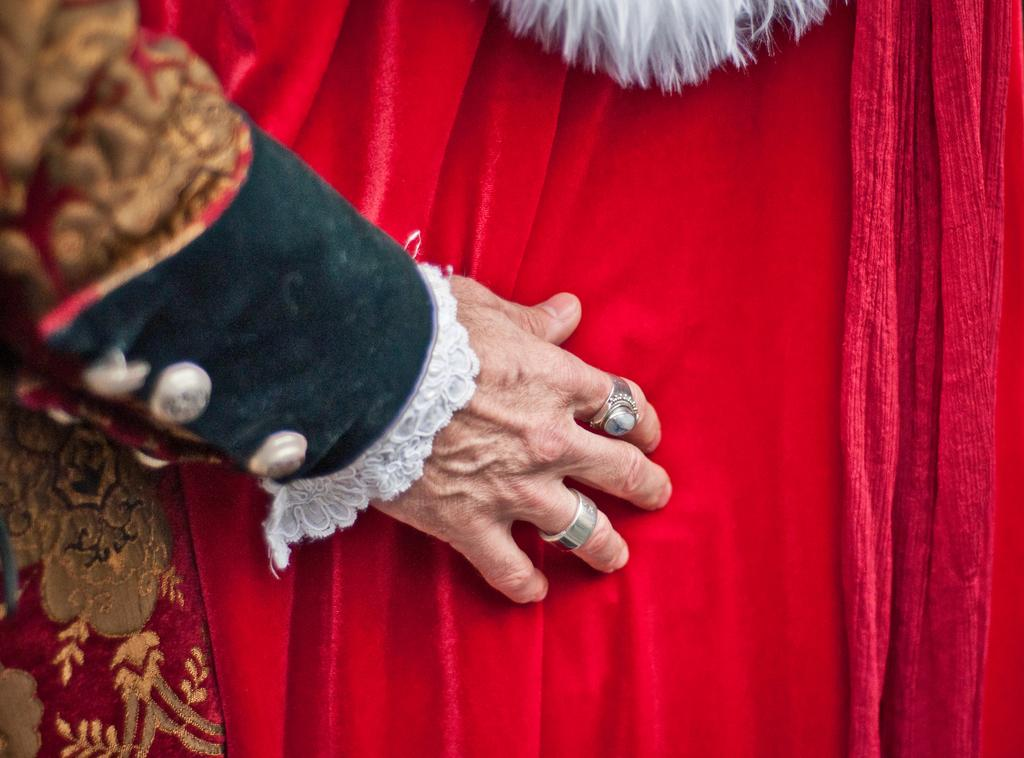What can be seen in the image? There is a hand in the image. What is the hand touching or resting on? The hand is placed on a red cloth. Are there any accessories on the hand? Yes, there are two rings on the fingers of the hand. What type of fork is being used by the hand in the image? There is no fork present in the image; it only shows a hand with two rings on a red cloth. 